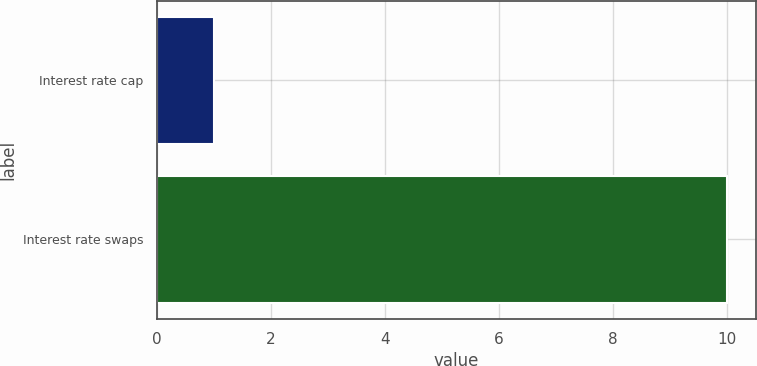Convert chart. <chart><loc_0><loc_0><loc_500><loc_500><bar_chart><fcel>Interest rate cap<fcel>Interest rate swaps<nl><fcel>1<fcel>10<nl></chart> 